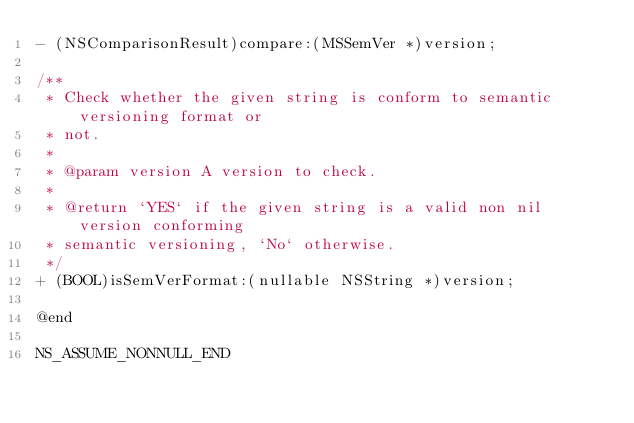Convert code to text. <code><loc_0><loc_0><loc_500><loc_500><_C_>- (NSComparisonResult)compare:(MSSemVer *)version;

/**
 * Check whether the given string is conform to semantic versioning format or
 * not.
 *
 * @param version A version to check.
 *
 * @return `YES` if the given string is a valid non nil version conforming
 * semantic versioning, `No` otherwise.
 */
+ (BOOL)isSemVerFormat:(nullable NSString *)version;

@end

NS_ASSUME_NONNULL_END
</code> 